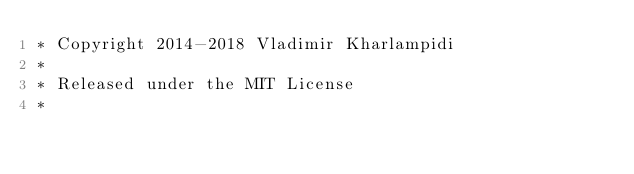<code> <loc_0><loc_0><loc_500><loc_500><_CSS_>* Copyright 2014-2018 Vladimir Kharlampidi
*
* Released under the MIT License
*</code> 